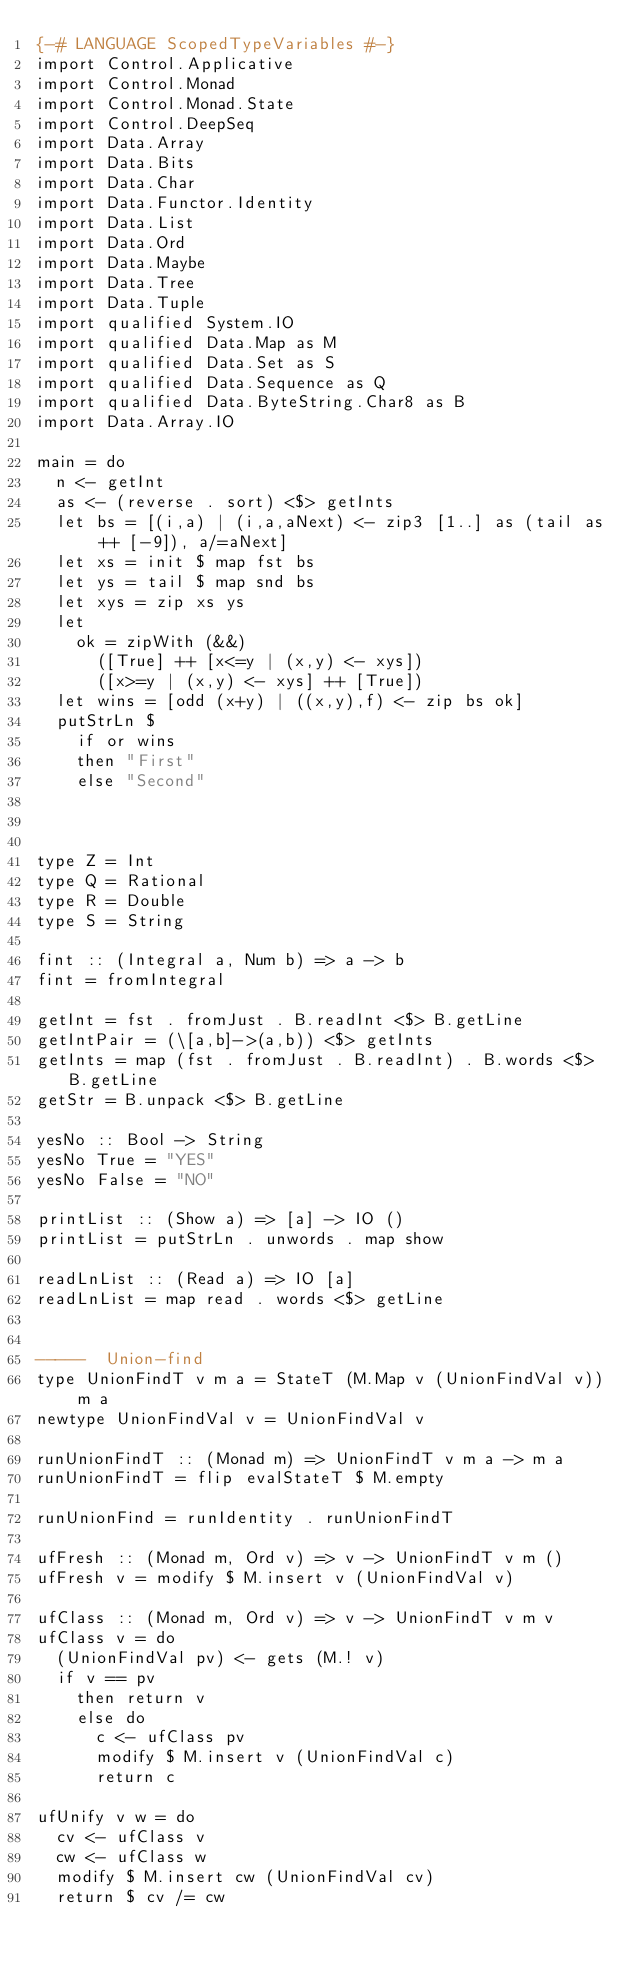Convert code to text. <code><loc_0><loc_0><loc_500><loc_500><_Haskell_>{-# LANGUAGE ScopedTypeVariables #-}
import Control.Applicative
import Control.Monad
import Control.Monad.State
import Control.DeepSeq
import Data.Array
import Data.Bits
import Data.Char
import Data.Functor.Identity
import Data.List
import Data.Ord
import Data.Maybe
import Data.Tree
import Data.Tuple
import qualified System.IO
import qualified Data.Map as M
import qualified Data.Set as S
import qualified Data.Sequence as Q
import qualified Data.ByteString.Char8 as B
import Data.Array.IO

main = do
  n <- getInt
  as <- (reverse . sort) <$> getInts
  let bs = [(i,a) | (i,a,aNext) <- zip3 [1..] as (tail as ++ [-9]), a/=aNext]
  let xs = init $ map fst bs
  let ys = tail $ map snd bs
  let xys = zip xs ys
  let
    ok = zipWith (&&)
      ([True] ++ [x<=y | (x,y) <- xys])
      ([x>=y | (x,y) <- xys] ++ [True])
  let wins = [odd (x+y) | ((x,y),f) <- zip bs ok]
  putStrLn $
    if or wins
    then "First"
    else "Second"


 
type Z = Int
type Q = Rational
type R = Double
type S = String

fint :: (Integral a, Num b) => a -> b
fint = fromIntegral

getInt = fst . fromJust . B.readInt <$> B.getLine
getIntPair = (\[a,b]->(a,b)) <$> getInts
getInts = map (fst . fromJust . B.readInt) . B.words <$> B.getLine
getStr = B.unpack <$> B.getLine

yesNo :: Bool -> String
yesNo True = "YES"
yesNo False = "NO"

printList :: (Show a) => [a] -> IO ()
printList = putStrLn . unwords . map show

readLnList :: (Read a) => IO [a]
readLnList = map read . words <$> getLine


-----  Union-find
type UnionFindT v m a = StateT (M.Map v (UnionFindVal v)) m a
newtype UnionFindVal v = UnionFindVal v

runUnionFindT :: (Monad m) => UnionFindT v m a -> m a
runUnionFindT = flip evalStateT $ M.empty

runUnionFind = runIdentity . runUnionFindT

ufFresh :: (Monad m, Ord v) => v -> UnionFindT v m ()
ufFresh v = modify $ M.insert v (UnionFindVal v)

ufClass :: (Monad m, Ord v) => v -> UnionFindT v m v
ufClass v = do
  (UnionFindVal pv) <- gets (M.! v)
  if v == pv
    then return v
    else do
      c <- ufClass pv
      modify $ M.insert v (UnionFindVal c)
      return c

ufUnify v w = do
  cv <- ufClass v
  cw <- ufClass w
  modify $ M.insert cw (UnionFindVal cv)
  return $ cv /= cw
</code> 